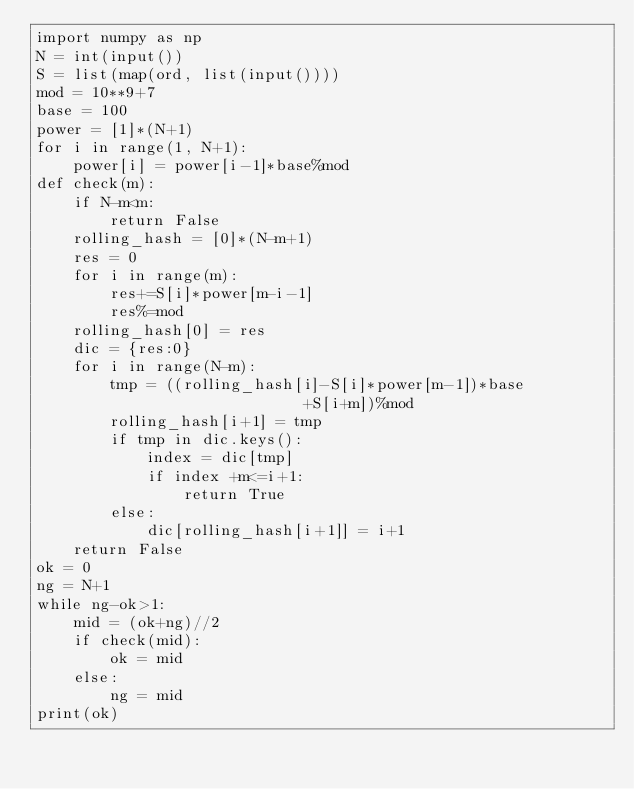Convert code to text. <code><loc_0><loc_0><loc_500><loc_500><_Python_>import numpy as np
N = int(input())
S = list(map(ord, list(input())))
mod = 10**9+7
base = 100
power = [1]*(N+1)
for i in range(1, N+1):
    power[i] = power[i-1]*base%mod
def check(m):
    if N-m<m:
        return False
    rolling_hash = [0]*(N-m+1)
    res = 0
    for i in range(m):
        res+=S[i]*power[m-i-1]
        res%=mod
    rolling_hash[0] = res
    dic = {res:0}
    for i in range(N-m):
        tmp = ((rolling_hash[i]-S[i]*power[m-1])*base
                             +S[i+m])%mod
        rolling_hash[i+1] = tmp
        if tmp in dic.keys():
            index = dic[tmp]
            if index +m<=i+1:
                return True
        else:
            dic[rolling_hash[i+1]] = i+1
    return False
ok = 0
ng = N+1
while ng-ok>1:
    mid = (ok+ng)//2
    if check(mid):
        ok = mid
    else:
        ng = mid
print(ok)
        
</code> 